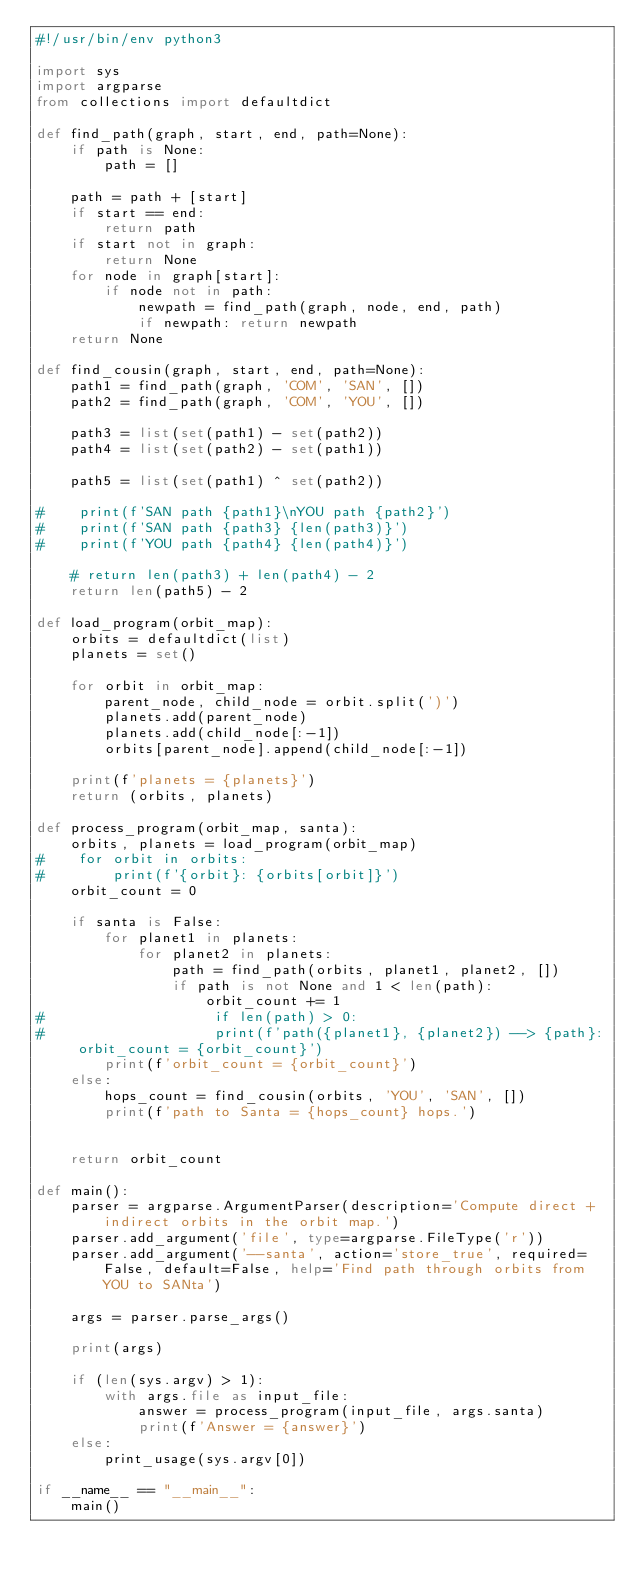<code> <loc_0><loc_0><loc_500><loc_500><_Python_>#!/usr/bin/env python3

import sys
import argparse
from collections import defaultdict

def find_path(graph, start, end, path=None):
    if path is None:
        path = []

    path = path + [start]
    if start == end:
        return path
    if start not in graph:
        return None
    for node in graph[start]:
        if node not in path:
            newpath = find_path(graph, node, end, path)
            if newpath: return newpath
    return None

def find_cousin(graph, start, end, path=None):
    path1 = find_path(graph, 'COM', 'SAN', [])
    path2 = find_path(graph, 'COM', 'YOU', [])

    path3 = list(set(path1) - set(path2))
    path4 = list(set(path2) - set(path1))

    path5 = list(set(path1) ^ set(path2))
    
#    print(f'SAN path {path1}\nYOU path {path2}')
#    print(f'SAN path {path3} {len(path3)}')
#    print(f'YOU path {path4} {len(path4)}')

    # return len(path3) + len(path4) - 2
    return len(path5) - 2

def load_program(orbit_map):
    orbits = defaultdict(list)
    planets = set()

    for orbit in orbit_map:
        parent_node, child_node = orbit.split(')')
        planets.add(parent_node)
        planets.add(child_node[:-1])
        orbits[parent_node].append(child_node[:-1])

    print(f'planets = {planets}')
    return (orbits, planets)

def process_program(orbit_map, santa):
    orbits, planets = load_program(orbit_map)
#    for orbit in orbits:
#        print(f'{orbit}: {orbits[orbit]}')
    orbit_count = 0

    if santa is False:
        for planet1 in planets:
            for planet2 in planets:
                path = find_path(orbits, planet1, planet2, []) 
                if path is not None and 1 < len(path):
                    orbit_count += 1
#                    if len(path) > 0:
#                    print(f'path({planet1}, {planet2}) --> {path}: orbit_count = {orbit_count}')
        print(f'orbit_count = {orbit_count}')
    else:
        hops_count = find_cousin(orbits, 'YOU', 'SAN', [])
        print(f'path to Santa = {hops_count} hops.')


    return orbit_count

def main():
    parser = argparse.ArgumentParser(description='Compute direct + indirect orbits in the orbit map.')
    parser.add_argument('file', type=argparse.FileType('r'))
    parser.add_argument('--santa', action='store_true', required=False, default=False, help='Find path through orbits from YOU to SANta')

    args = parser.parse_args()

    print(args)

    if (len(sys.argv) > 1):
        with args.file as input_file:
            answer = process_program(input_file, args.santa)
            print(f'Answer = {answer}')
    else:
        print_usage(sys.argv[0])

if __name__ == "__main__":
    main()
</code> 